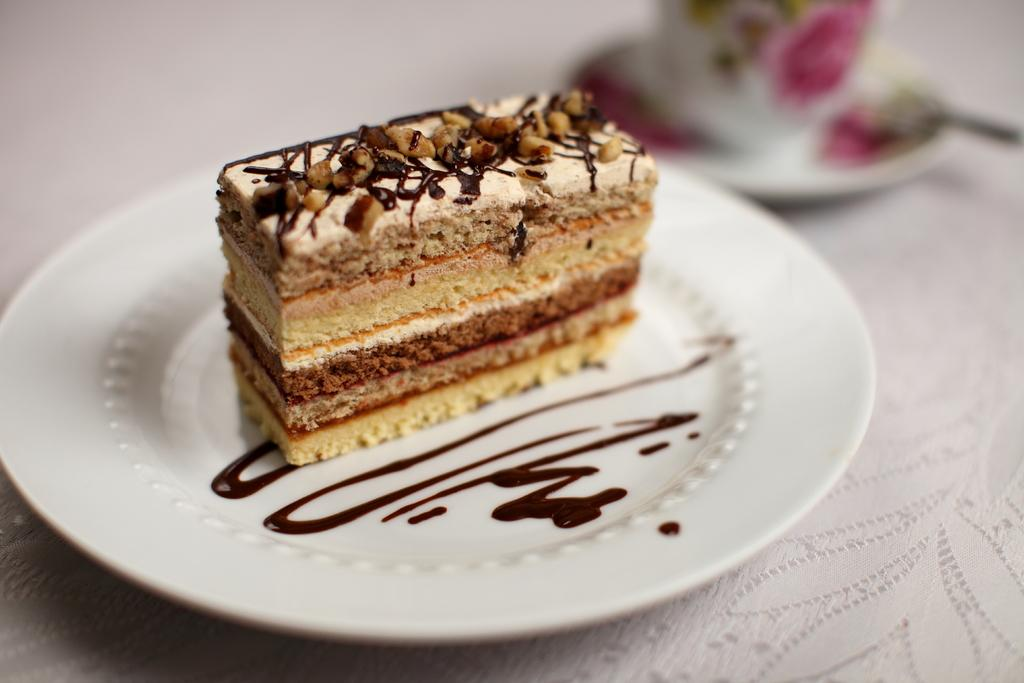What type of pastry is in the image? There is a chocolate pastry in the image. What is the chocolate pastry placed on? The chocolate pastry is on a white plate. What other item can be seen in the image besides the chocolate pastry? There is a colorful teacup in the image. Where is the teacup placed? The teacup is placed on a wooden table. How is the wooden table decorated or covered? The wooden table is covered with a white net cloth. What type of pipe is visible in the image? There is no pipe present in the image. What town is depicted in the background of the image? There is no town visible in the image. 